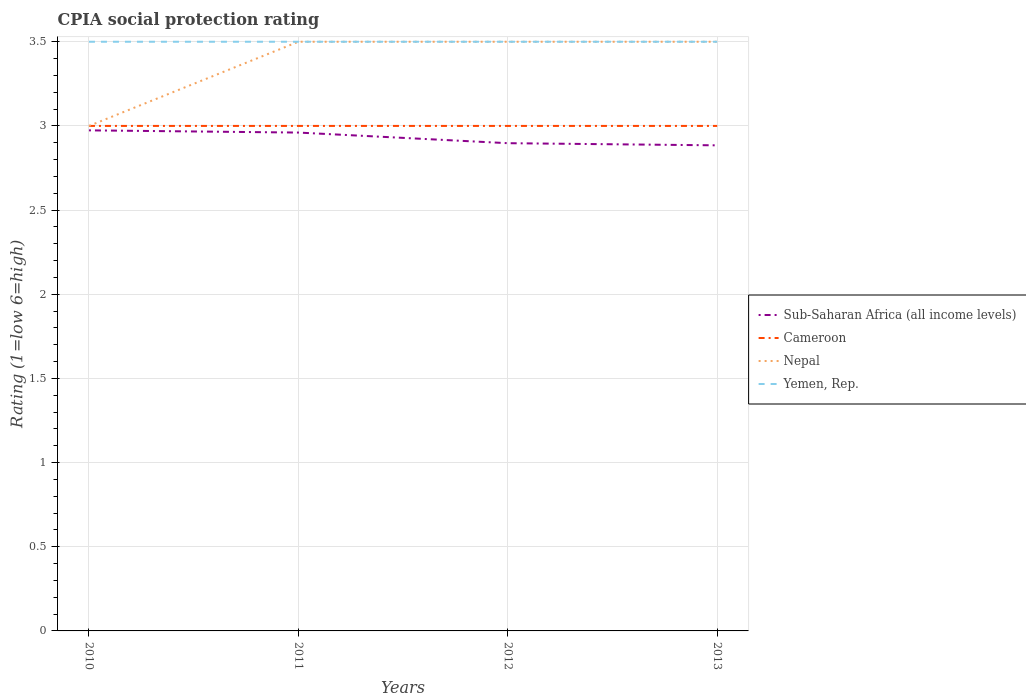How many different coloured lines are there?
Give a very brief answer. 4. Does the line corresponding to Nepal intersect with the line corresponding to Yemen, Rep.?
Your answer should be very brief. Yes. Is the number of lines equal to the number of legend labels?
Provide a succinct answer. Yes. Across all years, what is the maximum CPIA rating in Sub-Saharan Africa (all income levels)?
Provide a short and direct response. 2.88. How many lines are there?
Keep it short and to the point. 4. What is the difference between two consecutive major ticks on the Y-axis?
Your answer should be compact. 0.5. Are the values on the major ticks of Y-axis written in scientific E-notation?
Give a very brief answer. No. Does the graph contain any zero values?
Provide a short and direct response. No. Does the graph contain grids?
Provide a short and direct response. Yes. Where does the legend appear in the graph?
Offer a terse response. Center right. How many legend labels are there?
Keep it short and to the point. 4. What is the title of the graph?
Offer a very short reply. CPIA social protection rating. What is the Rating (1=low 6=high) of Sub-Saharan Africa (all income levels) in 2010?
Your response must be concise. 2.97. What is the Rating (1=low 6=high) in Cameroon in 2010?
Make the answer very short. 3. What is the Rating (1=low 6=high) in Nepal in 2010?
Offer a terse response. 3. What is the Rating (1=low 6=high) of Sub-Saharan Africa (all income levels) in 2011?
Give a very brief answer. 2.96. What is the Rating (1=low 6=high) of Cameroon in 2011?
Provide a short and direct response. 3. What is the Rating (1=low 6=high) in Nepal in 2011?
Provide a short and direct response. 3.5. What is the Rating (1=low 6=high) in Sub-Saharan Africa (all income levels) in 2012?
Your response must be concise. 2.9. What is the Rating (1=low 6=high) of Cameroon in 2012?
Your response must be concise. 3. What is the Rating (1=low 6=high) in Yemen, Rep. in 2012?
Offer a very short reply. 3.5. What is the Rating (1=low 6=high) of Sub-Saharan Africa (all income levels) in 2013?
Give a very brief answer. 2.88. What is the Rating (1=low 6=high) of Cameroon in 2013?
Your answer should be compact. 3. What is the Rating (1=low 6=high) of Yemen, Rep. in 2013?
Your answer should be very brief. 3.5. Across all years, what is the maximum Rating (1=low 6=high) in Sub-Saharan Africa (all income levels)?
Your answer should be compact. 2.97. Across all years, what is the minimum Rating (1=low 6=high) of Sub-Saharan Africa (all income levels)?
Provide a short and direct response. 2.88. Across all years, what is the minimum Rating (1=low 6=high) in Cameroon?
Ensure brevity in your answer.  3. Across all years, what is the minimum Rating (1=low 6=high) of Yemen, Rep.?
Provide a short and direct response. 3.5. What is the total Rating (1=low 6=high) of Sub-Saharan Africa (all income levels) in the graph?
Your answer should be very brief. 11.72. What is the total Rating (1=low 6=high) in Cameroon in the graph?
Your response must be concise. 12. What is the total Rating (1=low 6=high) of Nepal in the graph?
Make the answer very short. 13.5. What is the difference between the Rating (1=low 6=high) of Sub-Saharan Africa (all income levels) in 2010 and that in 2011?
Offer a very short reply. 0.01. What is the difference between the Rating (1=low 6=high) in Cameroon in 2010 and that in 2011?
Your answer should be very brief. 0. What is the difference between the Rating (1=low 6=high) of Yemen, Rep. in 2010 and that in 2011?
Ensure brevity in your answer.  0. What is the difference between the Rating (1=low 6=high) in Sub-Saharan Africa (all income levels) in 2010 and that in 2012?
Offer a terse response. 0.08. What is the difference between the Rating (1=low 6=high) of Yemen, Rep. in 2010 and that in 2012?
Make the answer very short. 0. What is the difference between the Rating (1=low 6=high) in Sub-Saharan Africa (all income levels) in 2010 and that in 2013?
Your answer should be compact. 0.09. What is the difference between the Rating (1=low 6=high) of Yemen, Rep. in 2010 and that in 2013?
Ensure brevity in your answer.  0. What is the difference between the Rating (1=low 6=high) in Sub-Saharan Africa (all income levels) in 2011 and that in 2012?
Offer a terse response. 0.06. What is the difference between the Rating (1=low 6=high) of Cameroon in 2011 and that in 2012?
Offer a very short reply. 0. What is the difference between the Rating (1=low 6=high) of Nepal in 2011 and that in 2012?
Ensure brevity in your answer.  0. What is the difference between the Rating (1=low 6=high) of Sub-Saharan Africa (all income levels) in 2011 and that in 2013?
Your response must be concise. 0.08. What is the difference between the Rating (1=low 6=high) in Sub-Saharan Africa (all income levels) in 2012 and that in 2013?
Keep it short and to the point. 0.01. What is the difference between the Rating (1=low 6=high) of Cameroon in 2012 and that in 2013?
Your answer should be very brief. 0. What is the difference between the Rating (1=low 6=high) of Yemen, Rep. in 2012 and that in 2013?
Offer a terse response. 0. What is the difference between the Rating (1=low 6=high) of Sub-Saharan Africa (all income levels) in 2010 and the Rating (1=low 6=high) of Cameroon in 2011?
Ensure brevity in your answer.  -0.03. What is the difference between the Rating (1=low 6=high) of Sub-Saharan Africa (all income levels) in 2010 and the Rating (1=low 6=high) of Nepal in 2011?
Give a very brief answer. -0.53. What is the difference between the Rating (1=low 6=high) of Sub-Saharan Africa (all income levels) in 2010 and the Rating (1=low 6=high) of Yemen, Rep. in 2011?
Your answer should be very brief. -0.53. What is the difference between the Rating (1=low 6=high) of Cameroon in 2010 and the Rating (1=low 6=high) of Nepal in 2011?
Provide a short and direct response. -0.5. What is the difference between the Rating (1=low 6=high) of Cameroon in 2010 and the Rating (1=low 6=high) of Yemen, Rep. in 2011?
Your answer should be compact. -0.5. What is the difference between the Rating (1=low 6=high) in Nepal in 2010 and the Rating (1=low 6=high) in Yemen, Rep. in 2011?
Keep it short and to the point. -0.5. What is the difference between the Rating (1=low 6=high) of Sub-Saharan Africa (all income levels) in 2010 and the Rating (1=low 6=high) of Cameroon in 2012?
Provide a short and direct response. -0.03. What is the difference between the Rating (1=low 6=high) of Sub-Saharan Africa (all income levels) in 2010 and the Rating (1=low 6=high) of Nepal in 2012?
Give a very brief answer. -0.53. What is the difference between the Rating (1=low 6=high) of Sub-Saharan Africa (all income levels) in 2010 and the Rating (1=low 6=high) of Yemen, Rep. in 2012?
Your response must be concise. -0.53. What is the difference between the Rating (1=low 6=high) in Nepal in 2010 and the Rating (1=low 6=high) in Yemen, Rep. in 2012?
Provide a short and direct response. -0.5. What is the difference between the Rating (1=low 6=high) of Sub-Saharan Africa (all income levels) in 2010 and the Rating (1=low 6=high) of Cameroon in 2013?
Make the answer very short. -0.03. What is the difference between the Rating (1=low 6=high) of Sub-Saharan Africa (all income levels) in 2010 and the Rating (1=low 6=high) of Nepal in 2013?
Provide a succinct answer. -0.53. What is the difference between the Rating (1=low 6=high) in Sub-Saharan Africa (all income levels) in 2010 and the Rating (1=low 6=high) in Yemen, Rep. in 2013?
Your response must be concise. -0.53. What is the difference between the Rating (1=low 6=high) in Nepal in 2010 and the Rating (1=low 6=high) in Yemen, Rep. in 2013?
Your response must be concise. -0.5. What is the difference between the Rating (1=low 6=high) in Sub-Saharan Africa (all income levels) in 2011 and the Rating (1=low 6=high) in Cameroon in 2012?
Your answer should be compact. -0.04. What is the difference between the Rating (1=low 6=high) of Sub-Saharan Africa (all income levels) in 2011 and the Rating (1=low 6=high) of Nepal in 2012?
Provide a short and direct response. -0.54. What is the difference between the Rating (1=low 6=high) of Sub-Saharan Africa (all income levels) in 2011 and the Rating (1=low 6=high) of Yemen, Rep. in 2012?
Your answer should be compact. -0.54. What is the difference between the Rating (1=low 6=high) of Cameroon in 2011 and the Rating (1=low 6=high) of Nepal in 2012?
Your response must be concise. -0.5. What is the difference between the Rating (1=low 6=high) in Nepal in 2011 and the Rating (1=low 6=high) in Yemen, Rep. in 2012?
Offer a very short reply. 0. What is the difference between the Rating (1=low 6=high) in Sub-Saharan Africa (all income levels) in 2011 and the Rating (1=low 6=high) in Cameroon in 2013?
Your answer should be very brief. -0.04. What is the difference between the Rating (1=low 6=high) of Sub-Saharan Africa (all income levels) in 2011 and the Rating (1=low 6=high) of Nepal in 2013?
Offer a terse response. -0.54. What is the difference between the Rating (1=low 6=high) in Sub-Saharan Africa (all income levels) in 2011 and the Rating (1=low 6=high) in Yemen, Rep. in 2013?
Offer a terse response. -0.54. What is the difference between the Rating (1=low 6=high) in Sub-Saharan Africa (all income levels) in 2012 and the Rating (1=low 6=high) in Cameroon in 2013?
Your answer should be very brief. -0.1. What is the difference between the Rating (1=low 6=high) of Sub-Saharan Africa (all income levels) in 2012 and the Rating (1=low 6=high) of Nepal in 2013?
Your response must be concise. -0.6. What is the difference between the Rating (1=low 6=high) in Sub-Saharan Africa (all income levels) in 2012 and the Rating (1=low 6=high) in Yemen, Rep. in 2013?
Offer a very short reply. -0.6. What is the difference between the Rating (1=low 6=high) of Cameroon in 2012 and the Rating (1=low 6=high) of Nepal in 2013?
Your answer should be compact. -0.5. What is the difference between the Rating (1=low 6=high) in Nepal in 2012 and the Rating (1=low 6=high) in Yemen, Rep. in 2013?
Your response must be concise. 0. What is the average Rating (1=low 6=high) in Sub-Saharan Africa (all income levels) per year?
Offer a very short reply. 2.93. What is the average Rating (1=low 6=high) in Nepal per year?
Provide a succinct answer. 3.38. What is the average Rating (1=low 6=high) of Yemen, Rep. per year?
Give a very brief answer. 3.5. In the year 2010, what is the difference between the Rating (1=low 6=high) of Sub-Saharan Africa (all income levels) and Rating (1=low 6=high) of Cameroon?
Offer a terse response. -0.03. In the year 2010, what is the difference between the Rating (1=low 6=high) of Sub-Saharan Africa (all income levels) and Rating (1=low 6=high) of Nepal?
Your response must be concise. -0.03. In the year 2010, what is the difference between the Rating (1=low 6=high) of Sub-Saharan Africa (all income levels) and Rating (1=low 6=high) of Yemen, Rep.?
Your response must be concise. -0.53. In the year 2010, what is the difference between the Rating (1=low 6=high) in Cameroon and Rating (1=low 6=high) in Yemen, Rep.?
Keep it short and to the point. -0.5. In the year 2011, what is the difference between the Rating (1=low 6=high) of Sub-Saharan Africa (all income levels) and Rating (1=low 6=high) of Cameroon?
Ensure brevity in your answer.  -0.04. In the year 2011, what is the difference between the Rating (1=low 6=high) of Sub-Saharan Africa (all income levels) and Rating (1=low 6=high) of Nepal?
Provide a succinct answer. -0.54. In the year 2011, what is the difference between the Rating (1=low 6=high) of Sub-Saharan Africa (all income levels) and Rating (1=low 6=high) of Yemen, Rep.?
Your response must be concise. -0.54. In the year 2012, what is the difference between the Rating (1=low 6=high) of Sub-Saharan Africa (all income levels) and Rating (1=low 6=high) of Cameroon?
Your answer should be very brief. -0.1. In the year 2012, what is the difference between the Rating (1=low 6=high) of Sub-Saharan Africa (all income levels) and Rating (1=low 6=high) of Nepal?
Offer a very short reply. -0.6. In the year 2012, what is the difference between the Rating (1=low 6=high) of Sub-Saharan Africa (all income levels) and Rating (1=low 6=high) of Yemen, Rep.?
Ensure brevity in your answer.  -0.6. In the year 2012, what is the difference between the Rating (1=low 6=high) in Cameroon and Rating (1=low 6=high) in Nepal?
Your response must be concise. -0.5. In the year 2012, what is the difference between the Rating (1=low 6=high) in Nepal and Rating (1=low 6=high) in Yemen, Rep.?
Your answer should be very brief. 0. In the year 2013, what is the difference between the Rating (1=low 6=high) of Sub-Saharan Africa (all income levels) and Rating (1=low 6=high) of Cameroon?
Your response must be concise. -0.12. In the year 2013, what is the difference between the Rating (1=low 6=high) of Sub-Saharan Africa (all income levels) and Rating (1=low 6=high) of Nepal?
Offer a very short reply. -0.62. In the year 2013, what is the difference between the Rating (1=low 6=high) of Sub-Saharan Africa (all income levels) and Rating (1=low 6=high) of Yemen, Rep.?
Make the answer very short. -0.62. What is the ratio of the Rating (1=low 6=high) of Sub-Saharan Africa (all income levels) in 2010 to that in 2011?
Keep it short and to the point. 1. What is the ratio of the Rating (1=low 6=high) of Nepal in 2010 to that in 2011?
Offer a very short reply. 0.86. What is the ratio of the Rating (1=low 6=high) of Sub-Saharan Africa (all income levels) in 2010 to that in 2012?
Offer a very short reply. 1.03. What is the ratio of the Rating (1=low 6=high) in Yemen, Rep. in 2010 to that in 2012?
Ensure brevity in your answer.  1. What is the ratio of the Rating (1=low 6=high) of Sub-Saharan Africa (all income levels) in 2010 to that in 2013?
Your answer should be compact. 1.03. What is the ratio of the Rating (1=low 6=high) in Cameroon in 2010 to that in 2013?
Provide a succinct answer. 1. What is the ratio of the Rating (1=low 6=high) of Sub-Saharan Africa (all income levels) in 2011 to that in 2012?
Keep it short and to the point. 1.02. What is the ratio of the Rating (1=low 6=high) in Cameroon in 2011 to that in 2012?
Provide a succinct answer. 1. What is the ratio of the Rating (1=low 6=high) in Nepal in 2011 to that in 2012?
Provide a short and direct response. 1. What is the ratio of the Rating (1=low 6=high) in Sub-Saharan Africa (all income levels) in 2011 to that in 2013?
Make the answer very short. 1.03. What is the ratio of the Rating (1=low 6=high) of Nepal in 2011 to that in 2013?
Provide a succinct answer. 1. What is the ratio of the Rating (1=low 6=high) in Yemen, Rep. in 2011 to that in 2013?
Give a very brief answer. 1. What is the ratio of the Rating (1=low 6=high) of Sub-Saharan Africa (all income levels) in 2012 to that in 2013?
Offer a very short reply. 1. What is the ratio of the Rating (1=low 6=high) of Cameroon in 2012 to that in 2013?
Your response must be concise. 1. What is the difference between the highest and the second highest Rating (1=low 6=high) of Sub-Saharan Africa (all income levels)?
Give a very brief answer. 0.01. What is the difference between the highest and the second highest Rating (1=low 6=high) of Cameroon?
Ensure brevity in your answer.  0. What is the difference between the highest and the lowest Rating (1=low 6=high) of Sub-Saharan Africa (all income levels)?
Keep it short and to the point. 0.09. What is the difference between the highest and the lowest Rating (1=low 6=high) in Cameroon?
Give a very brief answer. 0. What is the difference between the highest and the lowest Rating (1=low 6=high) in Nepal?
Provide a short and direct response. 0.5. 